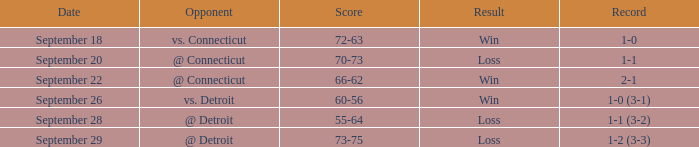What is the date with score of 66-62? September 22. 